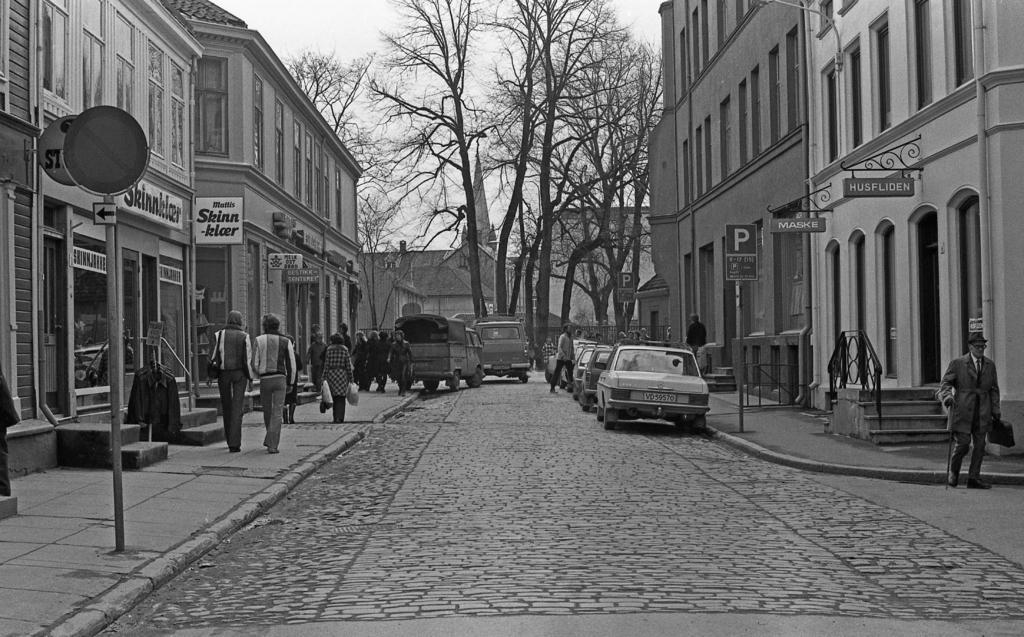Describe this image in one or two sentences. In this picture we can see many cars which is parked on the road. On the left we can see many peoples were walking on the street. On the right and left side we can see the buildings. In the background we can see many trees and there is a church. In the top left there is a sky. In the bottom left we can see the sign board. 